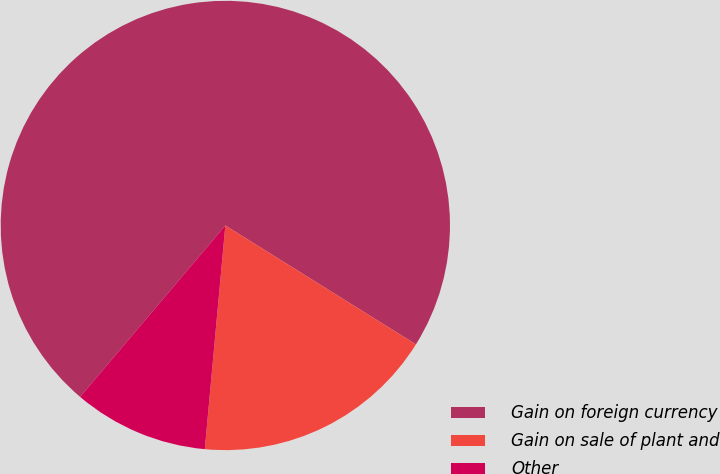Convert chart. <chart><loc_0><loc_0><loc_500><loc_500><pie_chart><fcel>Gain on foreign currency<fcel>Gain on sale of plant and<fcel>Other<nl><fcel>72.69%<fcel>17.58%<fcel>9.73%<nl></chart> 